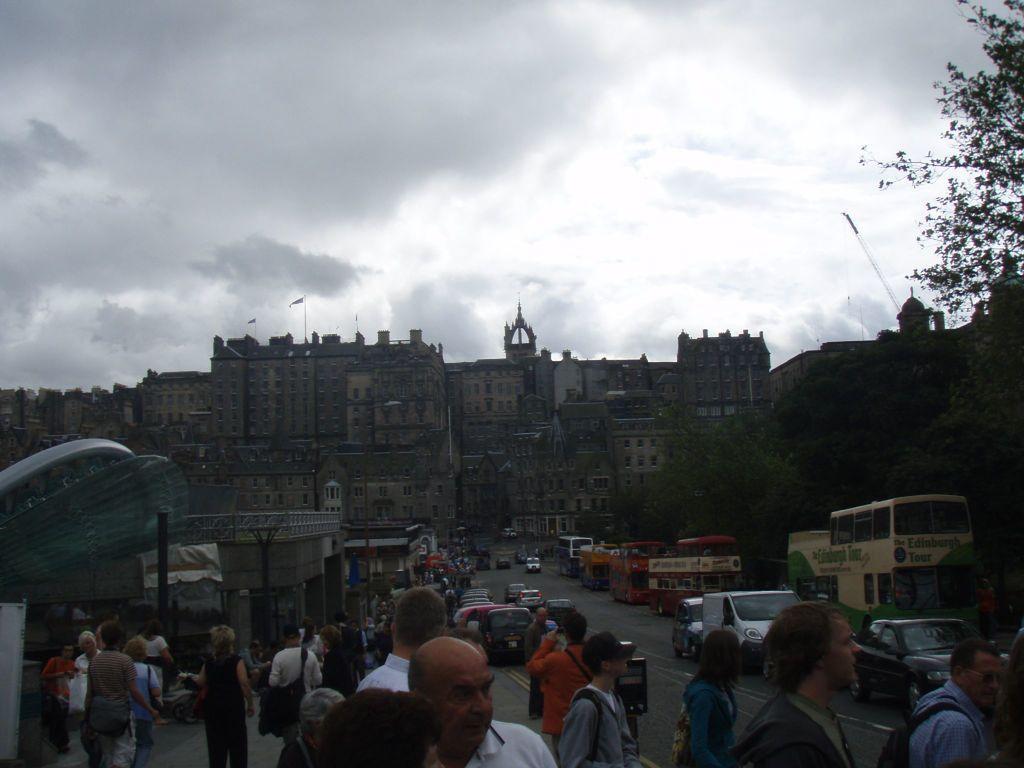In one or two sentences, can you explain what this image depicts? Here in this picture we can see number of people standing and walking on the road and we can also see number of buses and cars and other vehicles also present and we can see number of stores and buildings present and we can see plants and trees present and we can see flag posts present on the buildings and we can see clouds in the sky. 